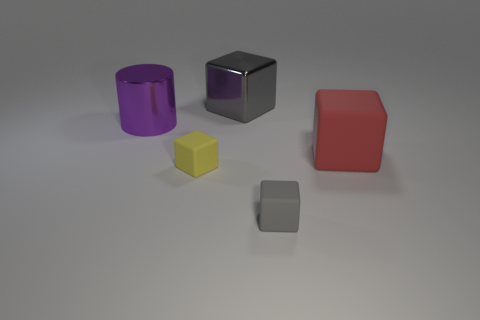How does the size of the purple object compare to others? The purple object, which is a cylinder, is the tallest in the scene and has a larger volume compared to the other shapes. Do the colors of the objects represent anything specific? Without additional context, it's not clear if the colors hold any specific representation. They seem to be chosen for visual contrast and demonstration purposes. 